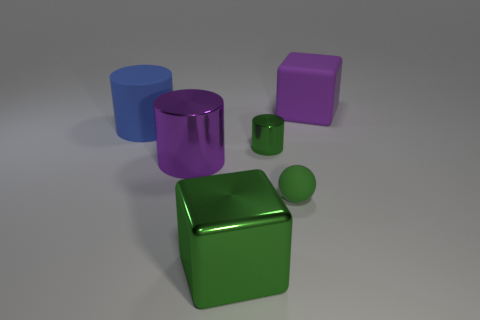Does the green object that is right of the green cylinder have the same shape as the big purple matte thing?
Your answer should be very brief. No. Is the number of big rubber things to the left of the matte cube less than the number of green cylinders that are in front of the tiny green rubber ball?
Provide a succinct answer. No. What is the material of the green cube?
Offer a terse response. Metal. There is a big shiny block; is it the same color as the metal cylinder behind the large purple metallic cylinder?
Ensure brevity in your answer.  Yes. How many matte objects are on the left side of the rubber block?
Provide a succinct answer. 2. Are there fewer large cylinders that are right of the tiny green ball than large blue cylinders?
Ensure brevity in your answer.  Yes. The tiny sphere is what color?
Ensure brevity in your answer.  Green. Does the large block behind the large green metal thing have the same color as the big metallic cylinder?
Your answer should be compact. Yes. What is the color of the shiny thing that is the same shape as the big purple rubber thing?
Keep it short and to the point. Green. How many large objects are cubes or green cylinders?
Provide a succinct answer. 2. 